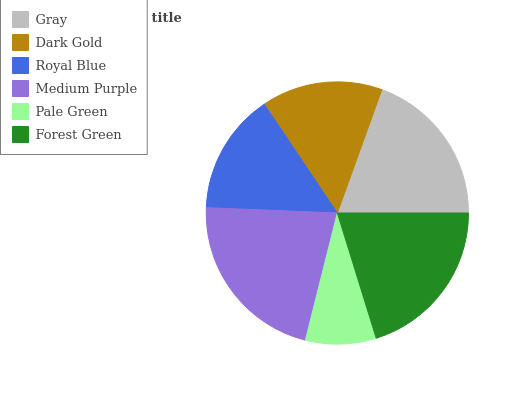Is Pale Green the minimum?
Answer yes or no. Yes. Is Medium Purple the maximum?
Answer yes or no. Yes. Is Dark Gold the minimum?
Answer yes or no. No. Is Dark Gold the maximum?
Answer yes or no. No. Is Gray greater than Dark Gold?
Answer yes or no. Yes. Is Dark Gold less than Gray?
Answer yes or no. Yes. Is Dark Gold greater than Gray?
Answer yes or no. No. Is Gray less than Dark Gold?
Answer yes or no. No. Is Gray the high median?
Answer yes or no. Yes. Is Royal Blue the low median?
Answer yes or no. Yes. Is Dark Gold the high median?
Answer yes or no. No. Is Gray the low median?
Answer yes or no. No. 